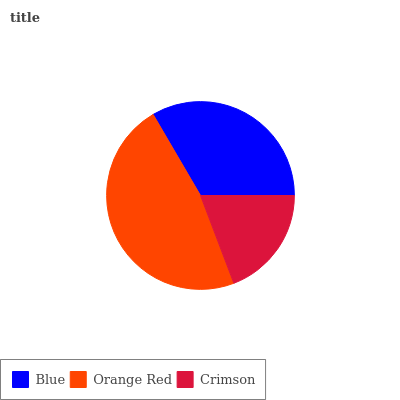Is Crimson the minimum?
Answer yes or no. Yes. Is Orange Red the maximum?
Answer yes or no. Yes. Is Orange Red the minimum?
Answer yes or no. No. Is Crimson the maximum?
Answer yes or no. No. Is Orange Red greater than Crimson?
Answer yes or no. Yes. Is Crimson less than Orange Red?
Answer yes or no. Yes. Is Crimson greater than Orange Red?
Answer yes or no. No. Is Orange Red less than Crimson?
Answer yes or no. No. Is Blue the high median?
Answer yes or no. Yes. Is Blue the low median?
Answer yes or no. Yes. Is Orange Red the high median?
Answer yes or no. No. Is Orange Red the low median?
Answer yes or no. No. 